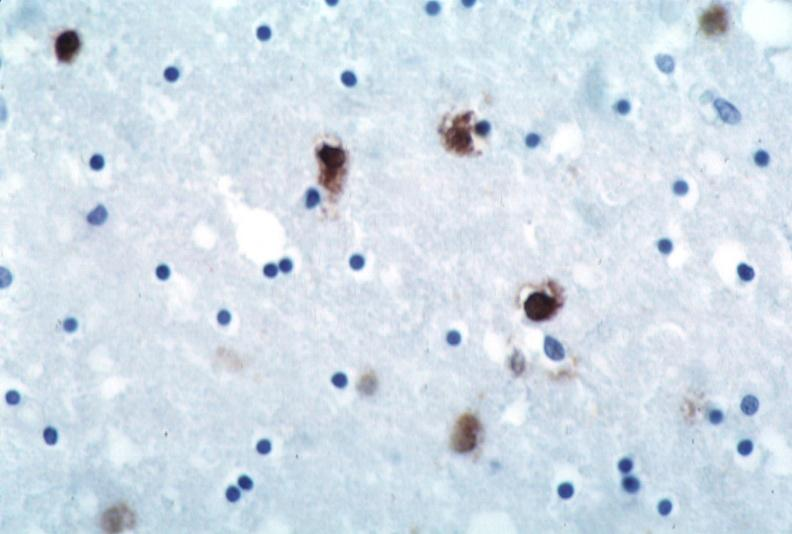does rheumatoid arthritis with vasculitis show brain, herpes encephalitis?
Answer the question using a single word or phrase. No 